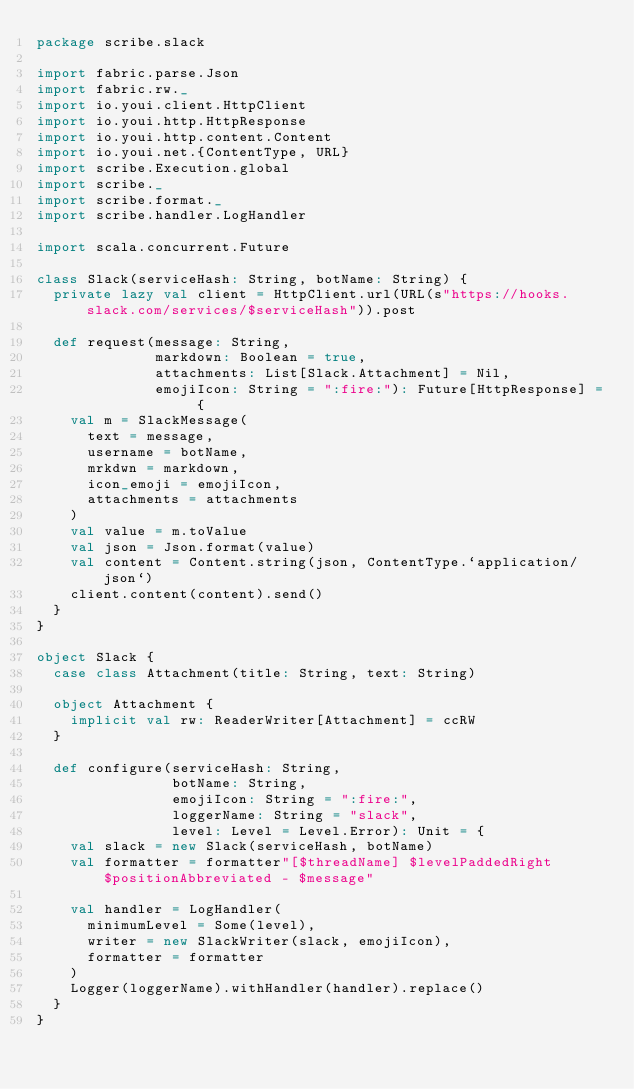<code> <loc_0><loc_0><loc_500><loc_500><_Scala_>package scribe.slack

import fabric.parse.Json
import fabric.rw._
import io.youi.client.HttpClient
import io.youi.http.HttpResponse
import io.youi.http.content.Content
import io.youi.net.{ContentType, URL}
import scribe.Execution.global
import scribe._
import scribe.format._
import scribe.handler.LogHandler

import scala.concurrent.Future

class Slack(serviceHash: String, botName: String) {
  private lazy val client = HttpClient.url(URL(s"https://hooks.slack.com/services/$serviceHash")).post

  def request(message: String,
              markdown: Boolean = true,
              attachments: List[Slack.Attachment] = Nil,
              emojiIcon: String = ":fire:"): Future[HttpResponse] = {
    val m = SlackMessage(
      text = message,
      username = botName,
      mrkdwn = markdown,
      icon_emoji = emojiIcon,
      attachments = attachments
    )
    val value = m.toValue
    val json = Json.format(value)
    val content = Content.string(json, ContentType.`application/json`)
    client.content(content).send()
  }
}

object Slack {
  case class Attachment(title: String, text: String)

  object Attachment {
    implicit val rw: ReaderWriter[Attachment] = ccRW
  }

  def configure(serviceHash: String,
                botName: String,
                emojiIcon: String = ":fire:",
                loggerName: String = "slack",
                level: Level = Level.Error): Unit = {
    val slack = new Slack(serviceHash, botName)
    val formatter = formatter"[$threadName] $levelPaddedRight $positionAbbreviated - $message"

    val handler = LogHandler(
      minimumLevel = Some(level),
      writer = new SlackWriter(slack, emojiIcon),
      formatter = formatter
    )
    Logger(loggerName).withHandler(handler).replace()
  }
}</code> 